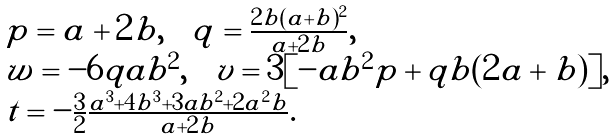<formula> <loc_0><loc_0><loc_500><loc_500>\begin{array} { l } p = a + 2 b , \quad q = \frac { 2 b ( a + b ) ^ { 2 } } { a + 2 b } , \\ w = - 6 q a b ^ { 2 } , \quad v = 3 [ - a b ^ { 2 } p + q b ( 2 a + b ) ] , \\ t = - \frac { 3 } { 2 } \frac { a ^ { 3 } + 4 b ^ { 3 } + 3 a b ^ { 2 } + 2 a ^ { 2 } b } { a + 2 b } . \end{array}</formula> 